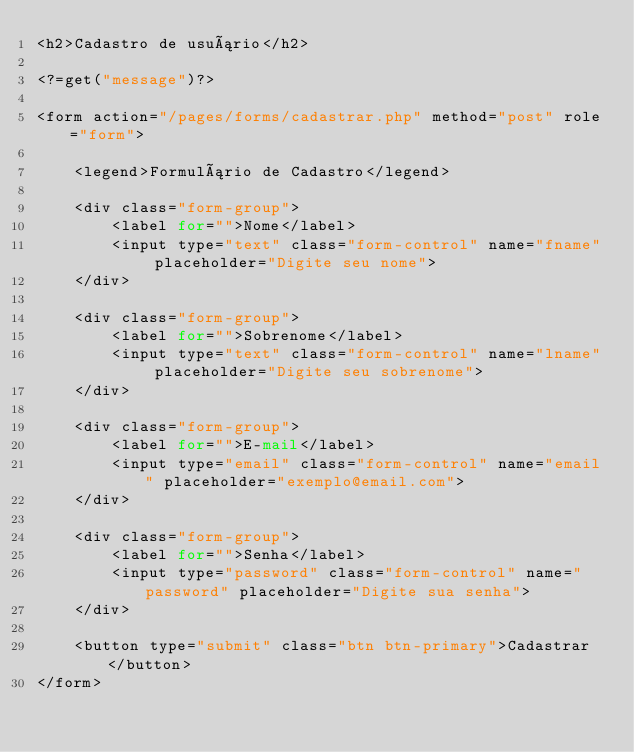Convert code to text. <code><loc_0><loc_0><loc_500><loc_500><_PHP_><h2>Cadastro de usuário</h2>

<?=get("message")?>

<form action="/pages/forms/cadastrar.php" method="post" role="form">

    <legend>Formulário de Cadastro</legend>

    <div class="form-group">
        <label for="">Nome</label>
        <input type="text" class="form-control" name="fname" placeholder="Digite seu nome">
    </div>

    <div class="form-group">
        <label for="">Sobrenome</label>
        <input type="text" class="form-control" name="lname" placeholder="Digite seu sobrenome">
    </div>

    <div class="form-group">
        <label for="">E-mail</label>
        <input type="email" class="form-control" name="email" placeholder="exemplo@email.com">
    </div>

    <div class="form-group">
        <label for="">Senha</label>
        <input type="password" class="form-control" name="password" placeholder="Digite sua senha">
    </div>

    <button type="submit" class="btn btn-primary">Cadastrar</button>
</form>
</code> 